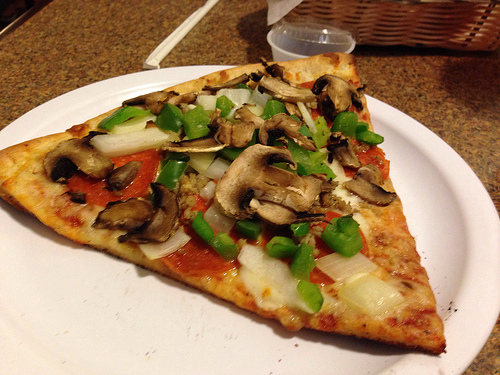What ingredients can you spot on the pizza in this picture? The pizza in the image features a variety of toppings, including cooked mushrooms, green bell peppers, onions, and slices of pepperoni. Can you describe what is to the side of the pizza? To the side of the pizza, there is a brown woven basket which appears to have a liner, suggesting it might have contained bread. Additionally, there is a small plastic container with a lid, possibly containing a dipping sauce. 